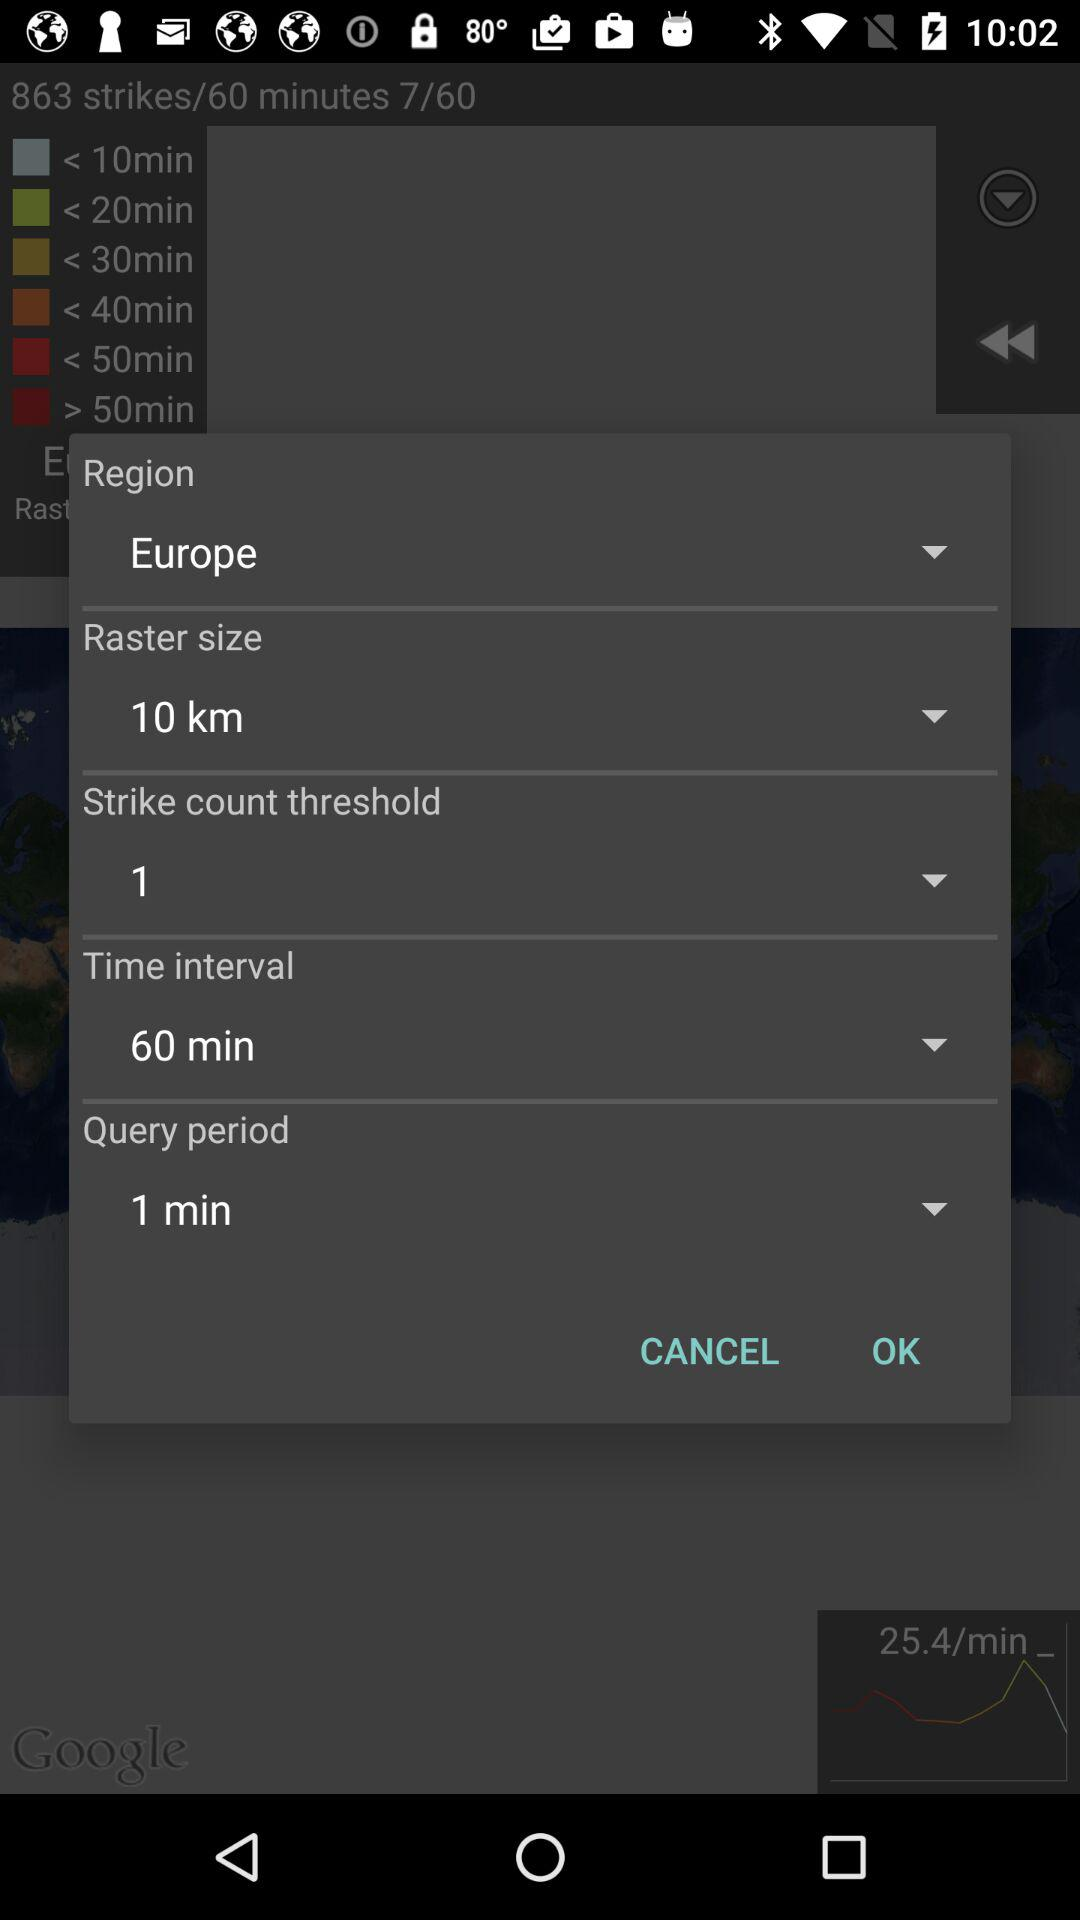What is the time interval? The time interval is 60 minutes. 